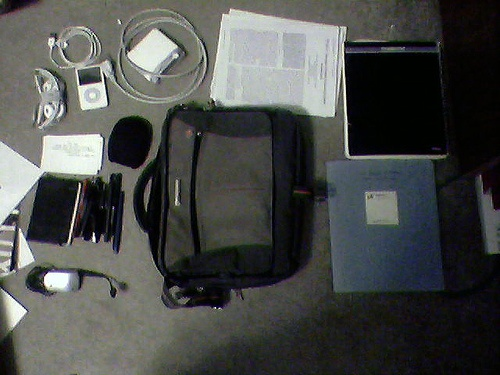Describe the objects in this image and their specific colors. I can see handbag in gray, black, and darkgreen tones, book in gray, blue, navy, and black tones, and cell phone in gray, ivory, black, and darkgray tones in this image. 